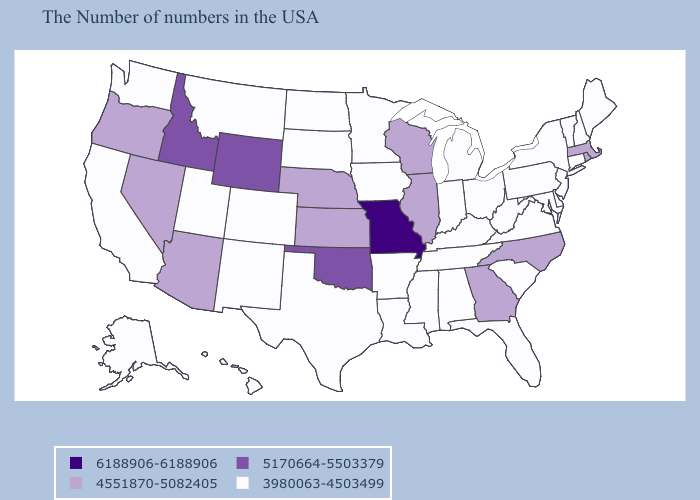Name the states that have a value in the range 6188906-6188906?
Short answer required. Missouri. Does Oklahoma have the highest value in the South?
Be succinct. Yes. What is the value of Wyoming?
Write a very short answer. 5170664-5503379. Name the states that have a value in the range 6188906-6188906?
Give a very brief answer. Missouri. Does Oregon have the lowest value in the USA?
Write a very short answer. No. Does Delaware have the same value as Georgia?
Short answer required. No. Among the states that border Iowa , which have the highest value?
Keep it brief. Missouri. Does Maryland have the same value as Oklahoma?
Be succinct. No. What is the value of Kentucky?
Answer briefly. 3980063-4503499. What is the value of North Carolina?
Be succinct. 4551870-5082405. What is the value of New Hampshire?
Short answer required. 3980063-4503499. Does the first symbol in the legend represent the smallest category?
Quick response, please. No. Does Massachusetts have the highest value in the Northeast?
Short answer required. Yes. Among the states that border South Dakota , which have the lowest value?
Keep it brief. Minnesota, Iowa, North Dakota, Montana. What is the lowest value in the MidWest?
Quick response, please. 3980063-4503499. 